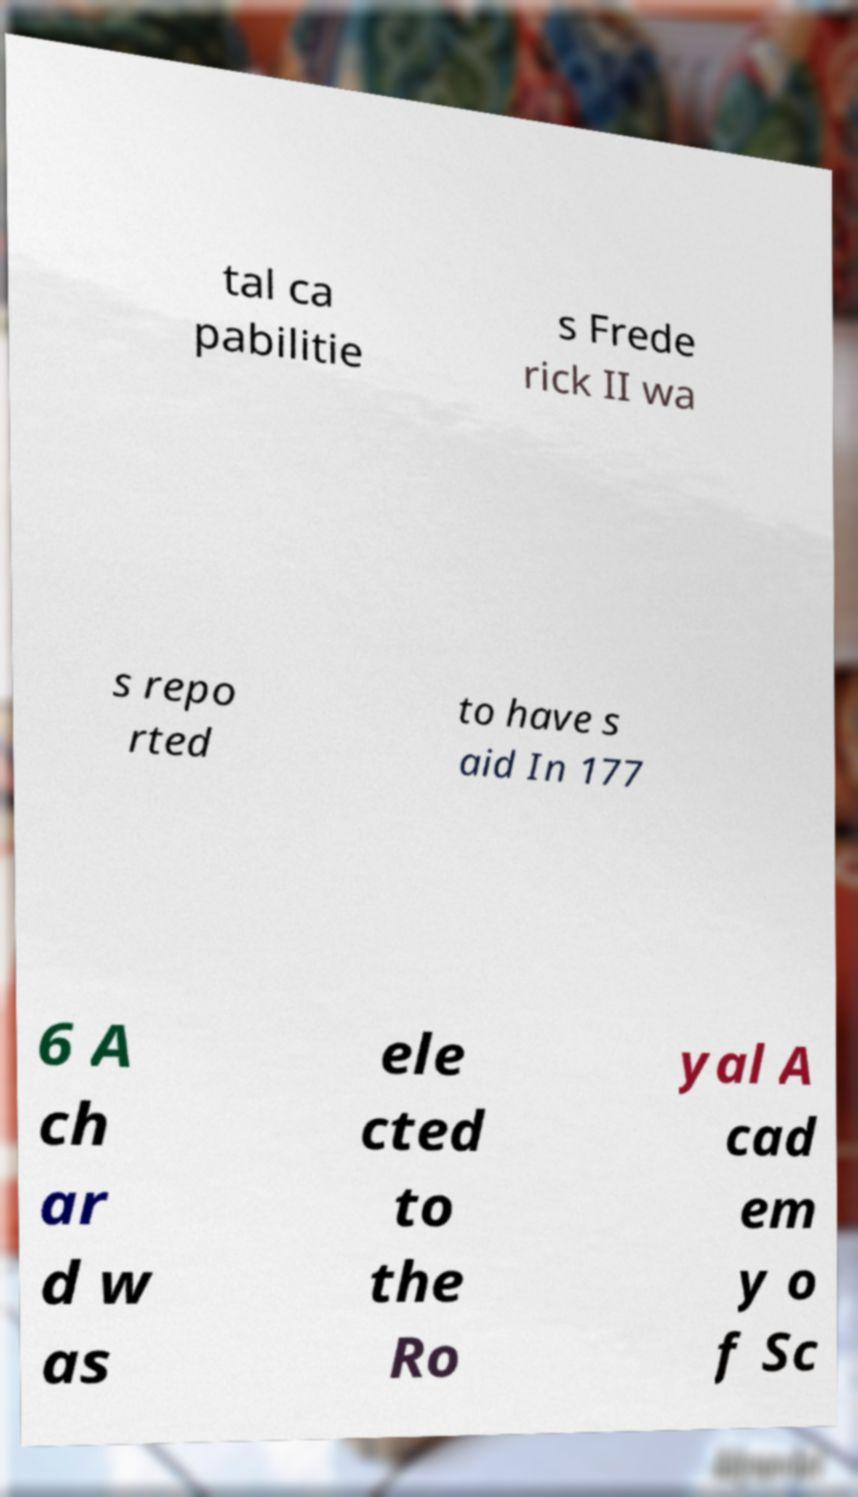Could you extract and type out the text from this image? tal ca pabilitie s Frede rick II wa s repo rted to have s aid In 177 6 A ch ar d w as ele cted to the Ro yal A cad em y o f Sc 